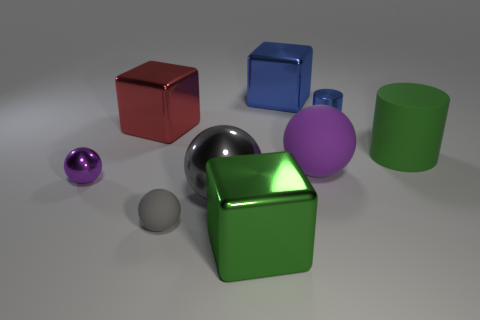Can you describe the lighting in this image? The image is uniformly lit with soft light coming from above as indicated by the soft shadows under the objects. The reflections on the surfaces of the metallic or shiny objects, such as the red cube and the chrome sphere, suggest a diffuse ambient light rather than a direct spotlight. 